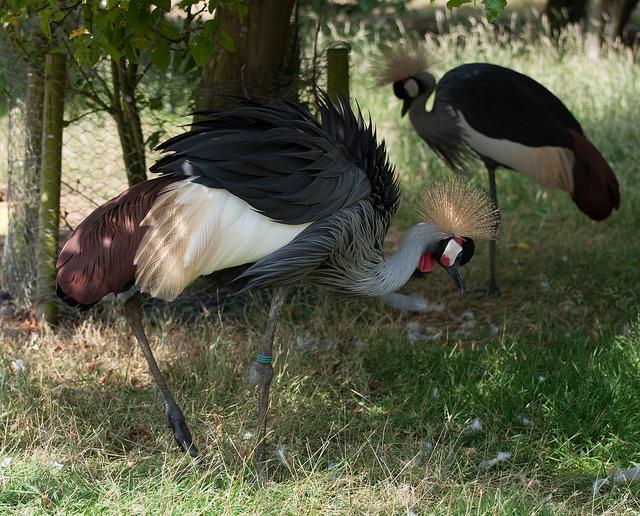Are these birds?
Give a very brief answer. Yes. How are they facing in relation to each other?
Concise answer only. Away from each other. What type of birds are these?
Answer briefly. Peacock. Are these birds tagged?
Be succinct. Yes. Are these ducklings in the picture?
Write a very short answer. No. 